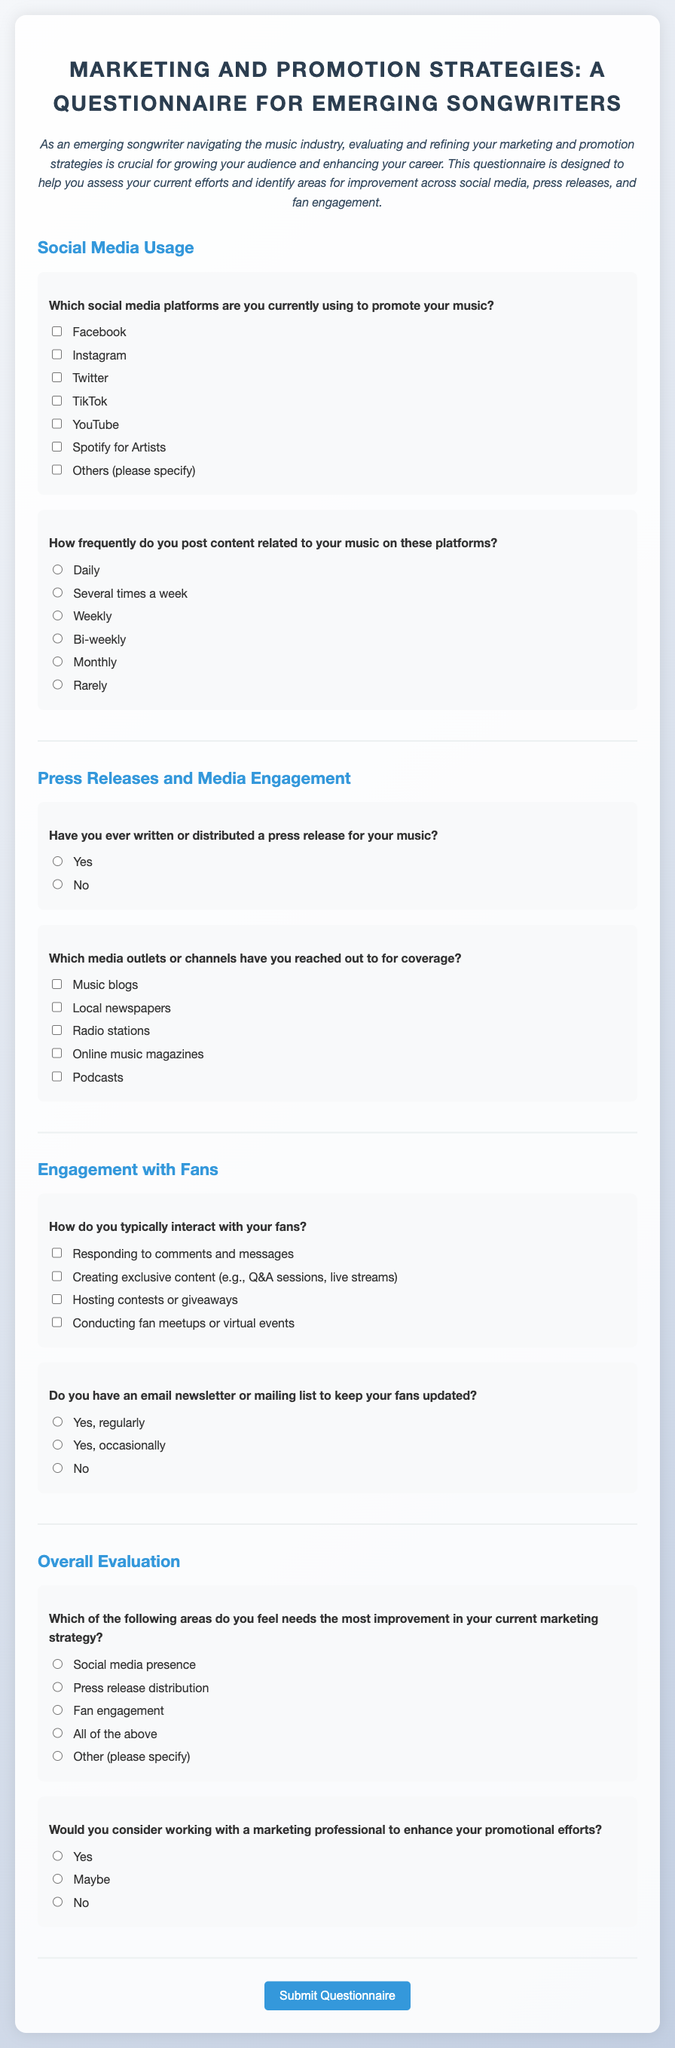What is the title of the questionnaire? The title is stated at the top of the document, summarizing the focus of the questionnaire for emerging songwriters.
Answer: Marketing and Promotion Strategies: A Questionnaire for Emerging Songwriters How many social media platforms are listed for promoting music? The questionnaire provides a list of platforms under the section on social media usage.
Answer: Six What is the most frequent posting option offered in the document? The questionnaire lists several posting frequency options, with one marked as the most frequent.
Answer: Daily What kind of engagement is suggested for fan interaction? The document lists several examples of how songwriters can interact with their fans.
Answer: Responding to comments and messages How many media outlet options are provided in the questionnaire? The document outlines various media outlets that songwriters may reach out to for coverage.
Answer: Five What improvement area is suggested for evaluation in marketing strategy? The document asks participants to identify which area needs the most improvement in their marketing strategy.
Answer: Social media presence Is there an option to specify "Other" in the improvement area question? The document provides various options for improvement areas, and one of them allows for a different input.
Answer: Yes What is one way to engage fans mentioned in the questionnaire? The document includes specific strategies for engaging with fans in one of its sections.
Answer: Creating exclusive content Do songwriters have the option to work with a marketing professional according to the document? The questionnaire includes a question that assesses if participants are open to collaborating with professionals.
Answer: Yes 